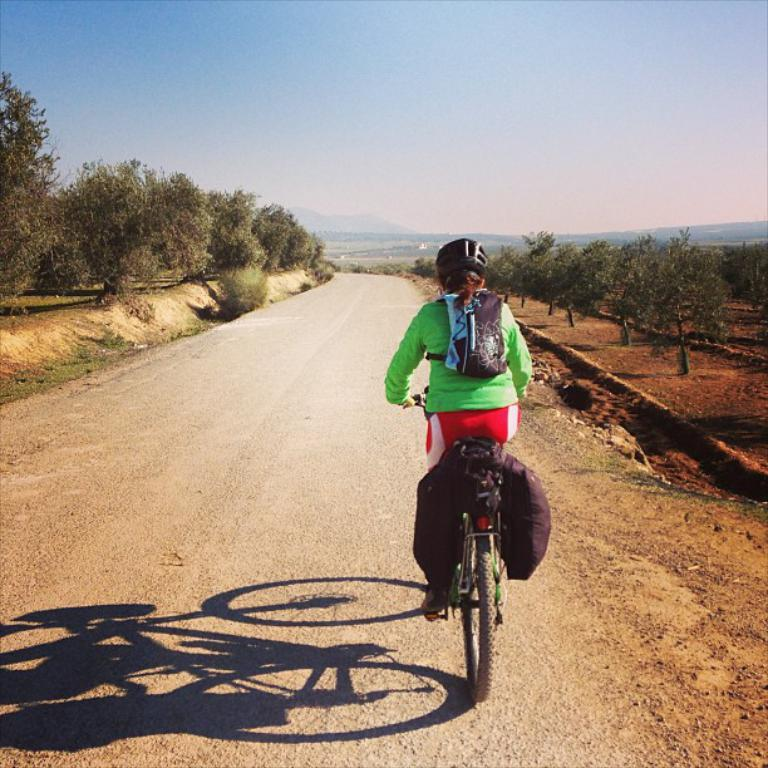Who is the main subject in the image? There is a girl in the image. What is the girl doing in the image? The girl is riding a bicycle. Is the girl wearing any safety gear in the image? Yes, the girl is wearing a helmet in the image. What can be seen in the background of the image? There is a road and trees on both sides of the image. What is visible at the top of the image? The sky is visible at the top of the image. What type of tub can be seen in the image? There is no tub present in the image; it features a girl riding a bicycle. What color is the girl's hair in the image? The color of the girl's hair is not mentioned in the image, so it cannot be determined. 